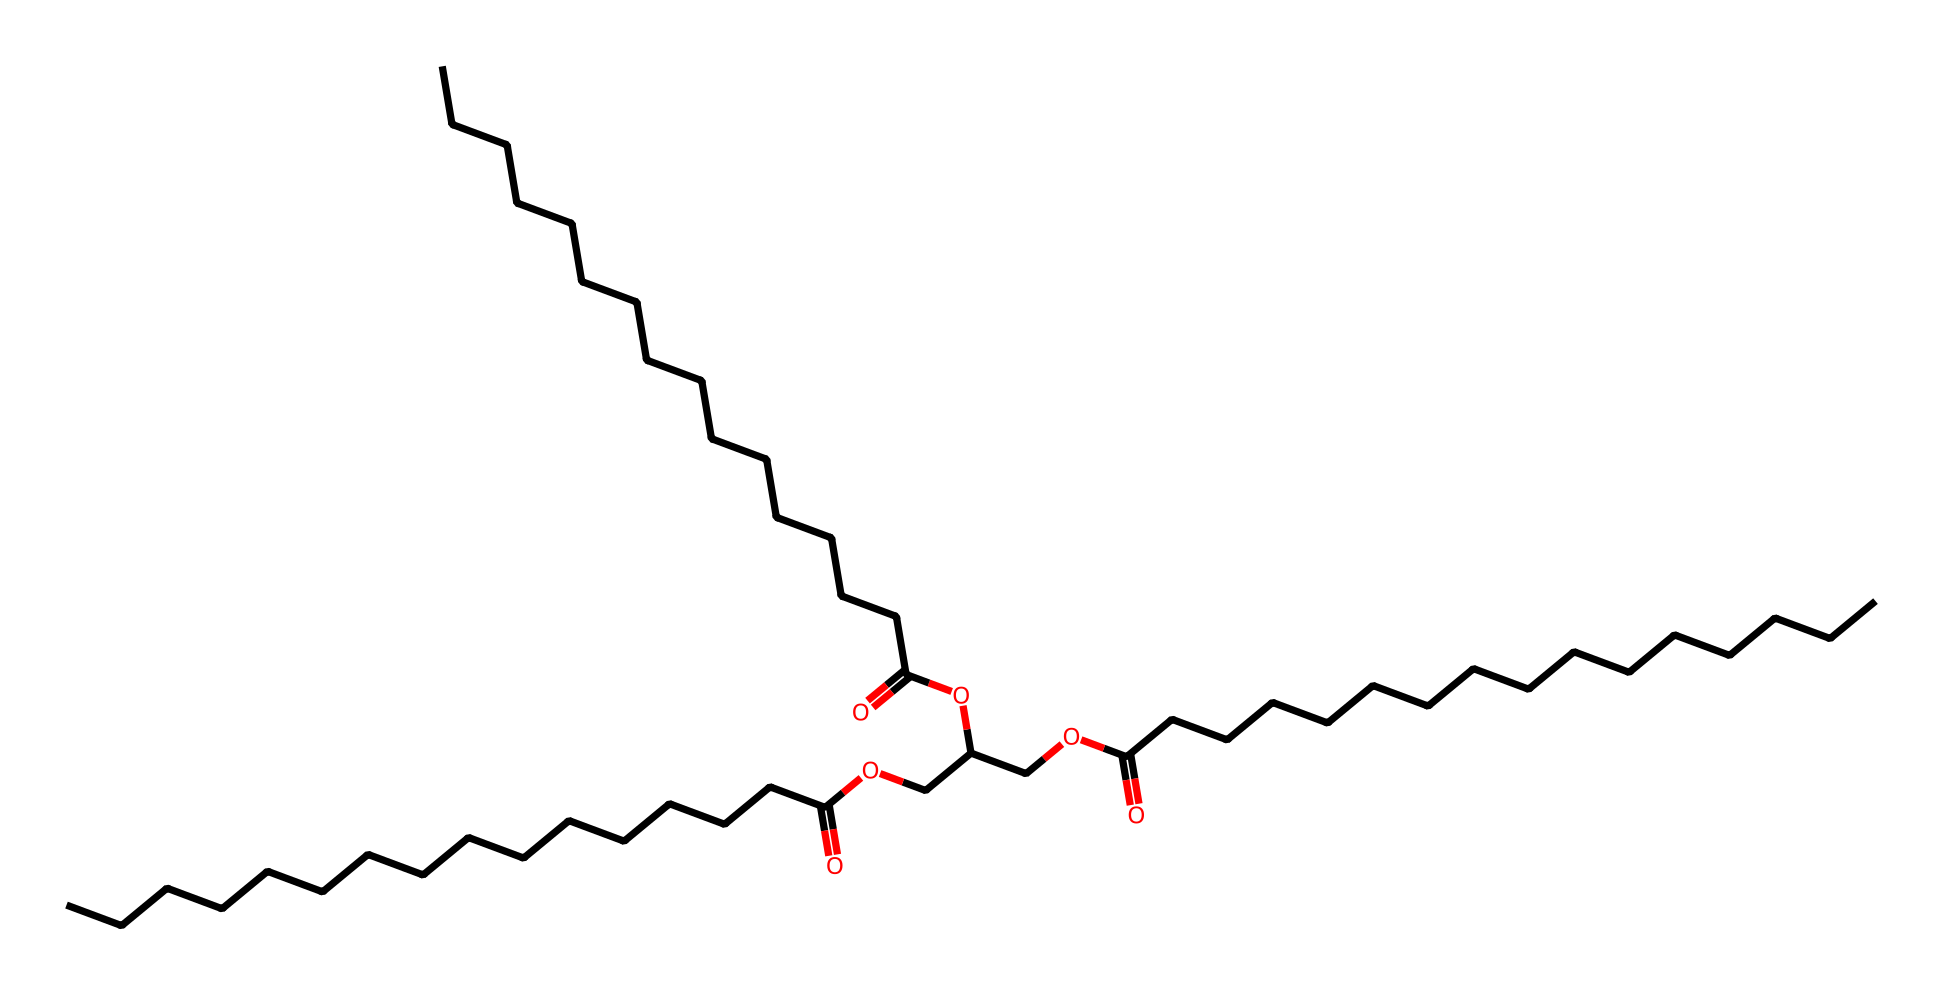What is the longest carbon chain in this lubricant? The longest carbon chain can be identified by looking at the structure and counting the continuous carbon atoms connected by single or double bonds. The longest chain in this structure consists of 18 carbon atoms.
Answer: 18 How many oxygen atoms are present in this chemical structure? By examining the SMILES representation, we can identify and count each 'O' symbol, which represents an oxygen atom. This structure contains 6 oxygen atoms.
Answer: 6 What functional group is present in the lubricant that indicates it is an ester? The presence of the 'OC(=O)' section in the structure indicates the ester functional group, characterized by a carbonyl (C=O) bonded to an oxygen atom (O).
Answer: ester What property of this lubricant indicates it is environmentally friendly? The use of long carbon chains from natural sources suggests that this lubricant is biodegradable, which is a key property of environmentally friendly lubricants.
Answer: biodegradable Is this lubricant likely to be viscous? Given the long carbon chains indicated in the structure, lubricants with longer hydrocarbon chains typically have higher viscosity, making this lubricant likely viscous.
Answer: likely viscous 